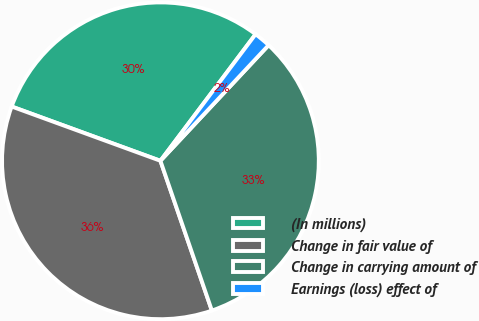Convert chart. <chart><loc_0><loc_0><loc_500><loc_500><pie_chart><fcel>(In millions)<fcel>Change in fair value of<fcel>Change in carrying amount of<fcel>Earnings (loss) effect of<nl><fcel>29.69%<fcel>35.83%<fcel>32.76%<fcel>1.71%<nl></chart> 